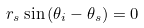Convert formula to latex. <formula><loc_0><loc_0><loc_500><loc_500>r _ { s } \sin { ( \theta _ { i } - \theta _ { s } ) } = 0</formula> 